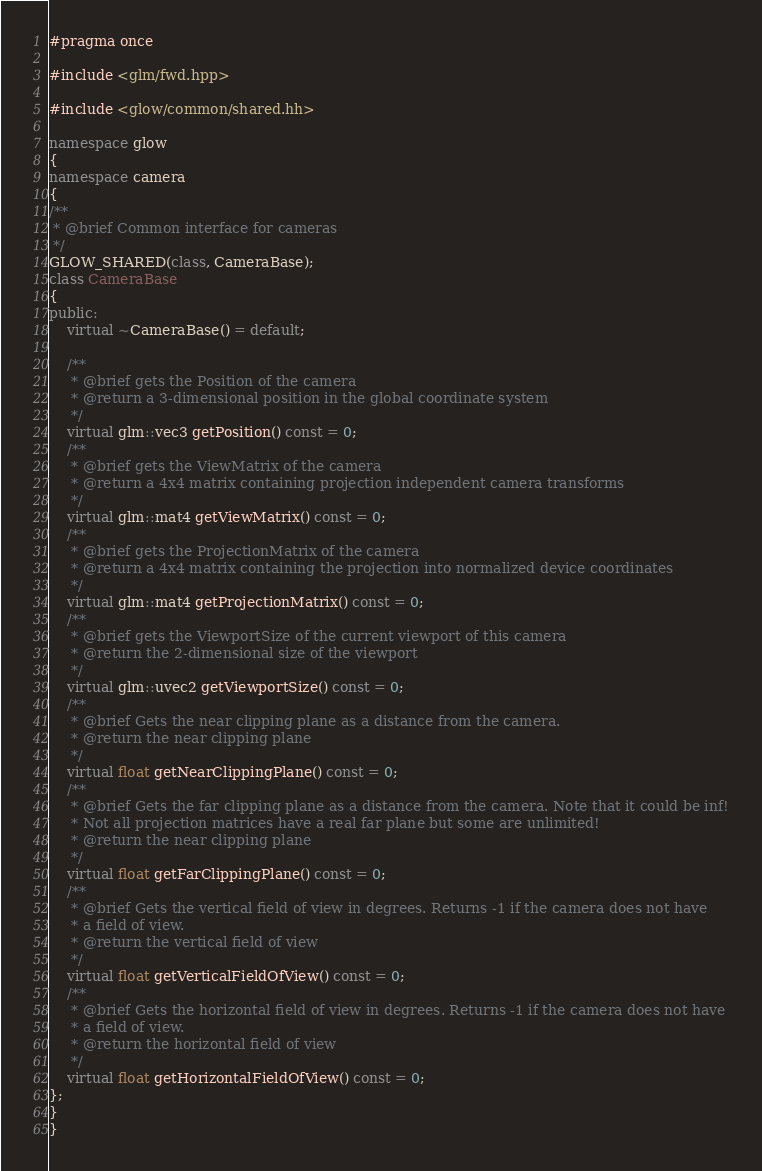<code> <loc_0><loc_0><loc_500><loc_500><_C++_>#pragma once

#include <glm/fwd.hpp>

#include <glow/common/shared.hh>

namespace glow
{
namespace camera
{
/**
 * @brief Common interface for cameras
 */
GLOW_SHARED(class, CameraBase);
class CameraBase
{
public:
    virtual ~CameraBase() = default;

    /**
     * @brief gets the Position of the camera
     * @return a 3-dimensional position in the global coordinate system
     */
    virtual glm::vec3 getPosition() const = 0;
    /**
     * @brief gets the ViewMatrix of the camera
     * @return a 4x4 matrix containing projection independent camera transforms
     */
    virtual glm::mat4 getViewMatrix() const = 0;
    /**
     * @brief gets the ProjectionMatrix of the camera
     * @return a 4x4 matrix containing the projection into normalized device coordinates
     */
    virtual glm::mat4 getProjectionMatrix() const = 0;
    /**
     * @brief gets the ViewportSize of the current viewport of this camera
     * @return the 2-dimensional size of the viewport
     */
    virtual glm::uvec2 getViewportSize() const = 0;
    /**
     * @brief Gets the near clipping plane as a distance from the camera.
     * @return the near clipping plane
     */
    virtual float getNearClippingPlane() const = 0;
    /**
     * @brief Gets the far clipping plane as a distance from the camera. Note that it could be inf!
     * Not all projection matrices have a real far plane but some are unlimited!
     * @return the near clipping plane
     */
    virtual float getFarClippingPlane() const = 0;
    /**
     * @brief Gets the vertical field of view in degrees. Returns -1 if the camera does not have
     * a field of view.
     * @return the vertical field of view
     */
    virtual float getVerticalFieldOfView() const = 0;
    /**
     * @brief Gets the horizontal field of view in degrees. Returns -1 if the camera does not have
     * a field of view.
     * @return the horizontal field of view
     */
    virtual float getHorizontalFieldOfView() const = 0;
};
}
}
</code> 